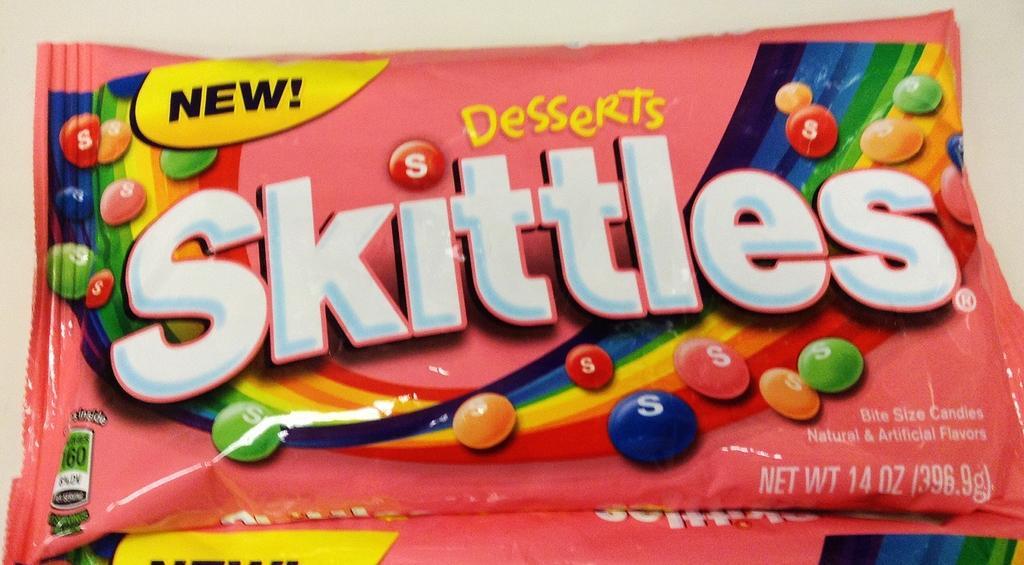Can you describe this image briefly? In this image there is a food packet. There are numbers and text on the food packet. 